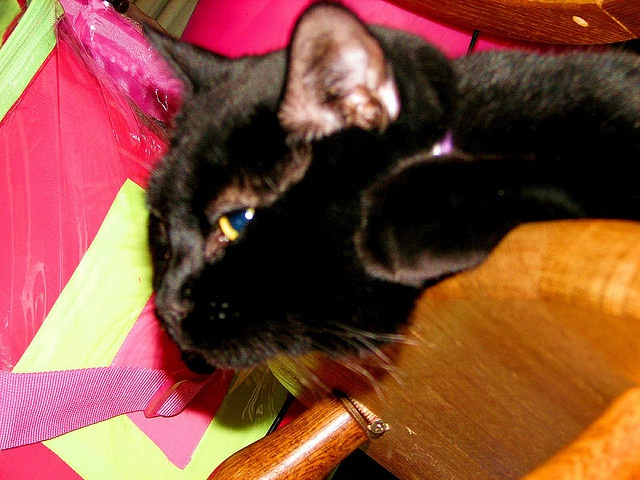Describe the objects in this image and their specific colors. I can see cat in olive, black, maroon, and gray tones and chair in olive, brown, orange, red, and maroon tones in this image. 